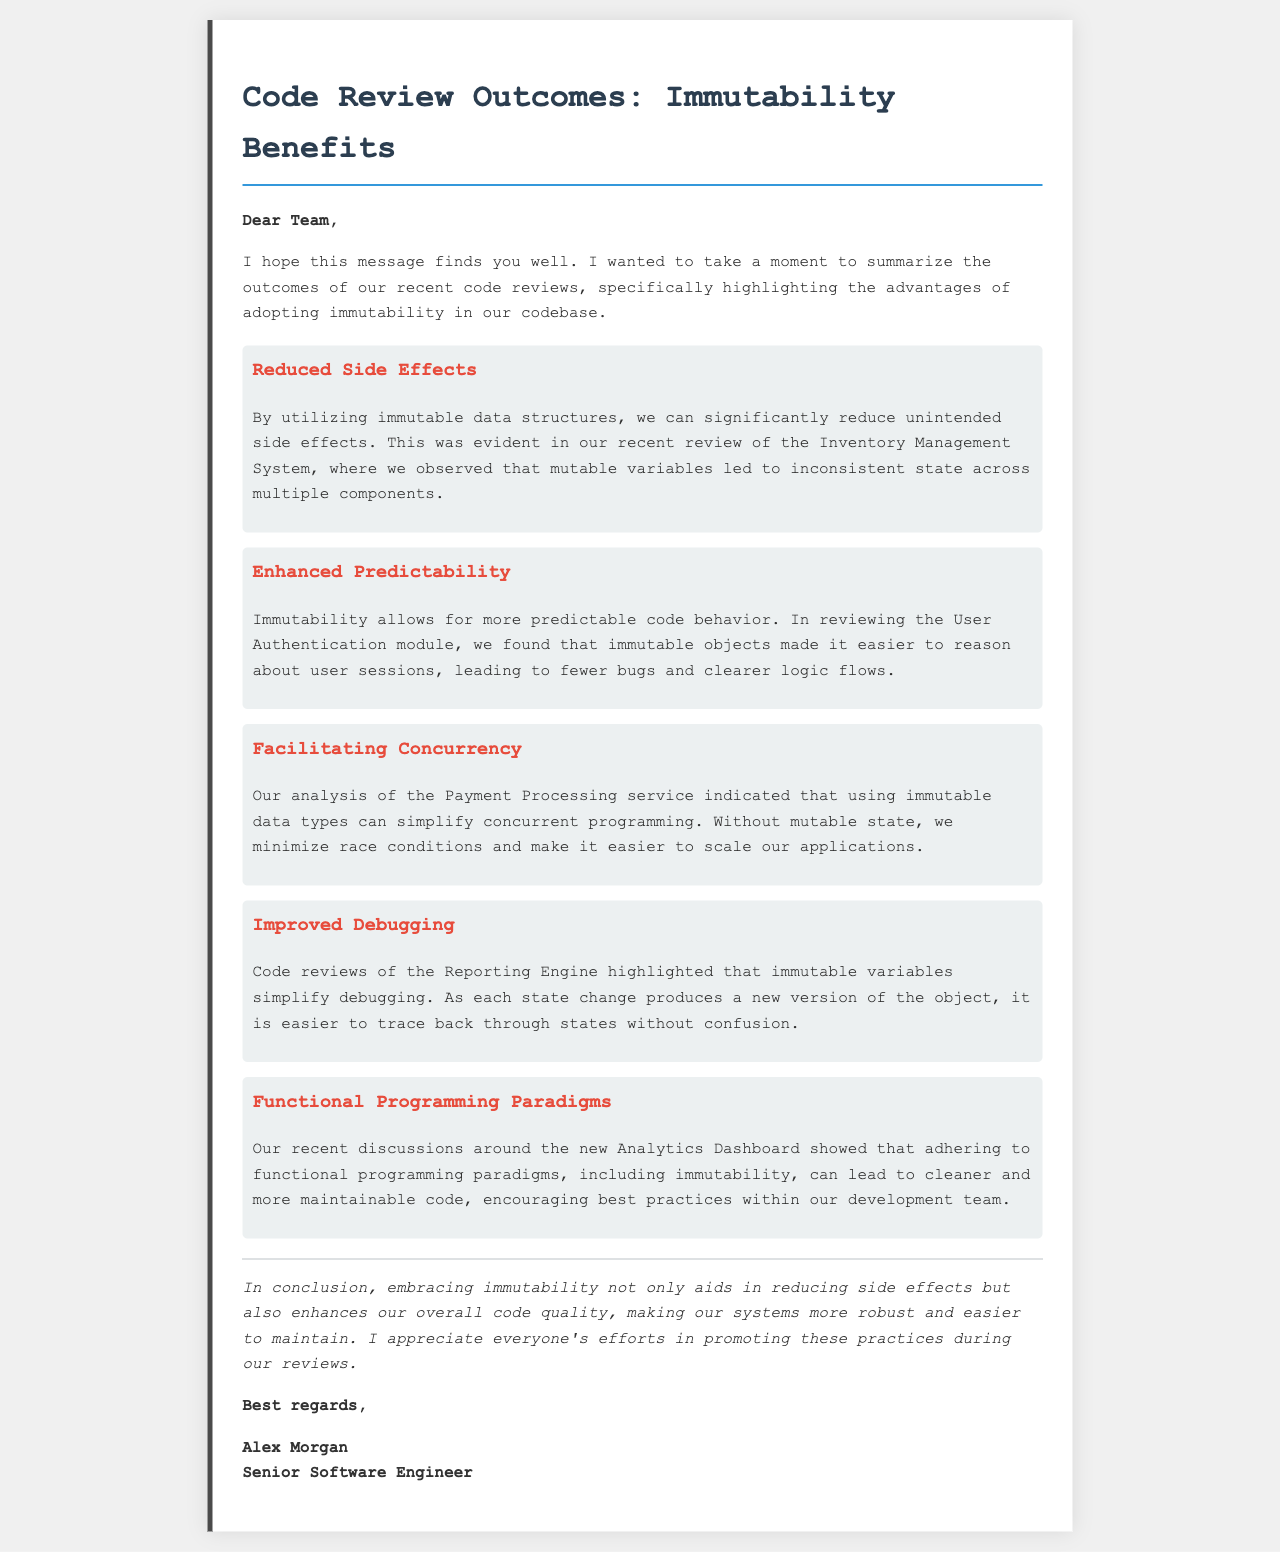What is the title of the letter? The title of the letter is stated in the heading, summarizing the main topic discussed.
Answer: Code Review Outcomes: Immutability Benefits Who is the author of the letter? The author's name is found in the closing section of the letter, indicating who wrote it.
Answer: Alex Morgan What benefit is associated with reduced side effects? The letter mentions specific benefits of immutability in various components of the system related to side effects.
Answer: Inventory Management System Which programming paradigm is mentioned in relation to immutability? The letter discusses programming practices, highlighting a specific paradigm that relates to immutability.
Answer: Functional Programming Paradigms How many benefits of immutability are outlined in the letter? The letter lists various advantages, which can be counted to obtain a total.
Answer: Five What module was reviewed to highlight enhanced predictability? The letter specifies a module that was evaluated for its predictable behavior when following certain practices.
Answer: User Authentication Which service indicated simplicity in concurrent programming due to immutability? The letter references a specific service related to handling of data types for improving concurrency.
Answer: Payment Processing service What is the overall conclusion regarding immutability? The conclusion summarizes the overall impact of adopting immutability in the codebase.
Answer: Enhances overall code quality 